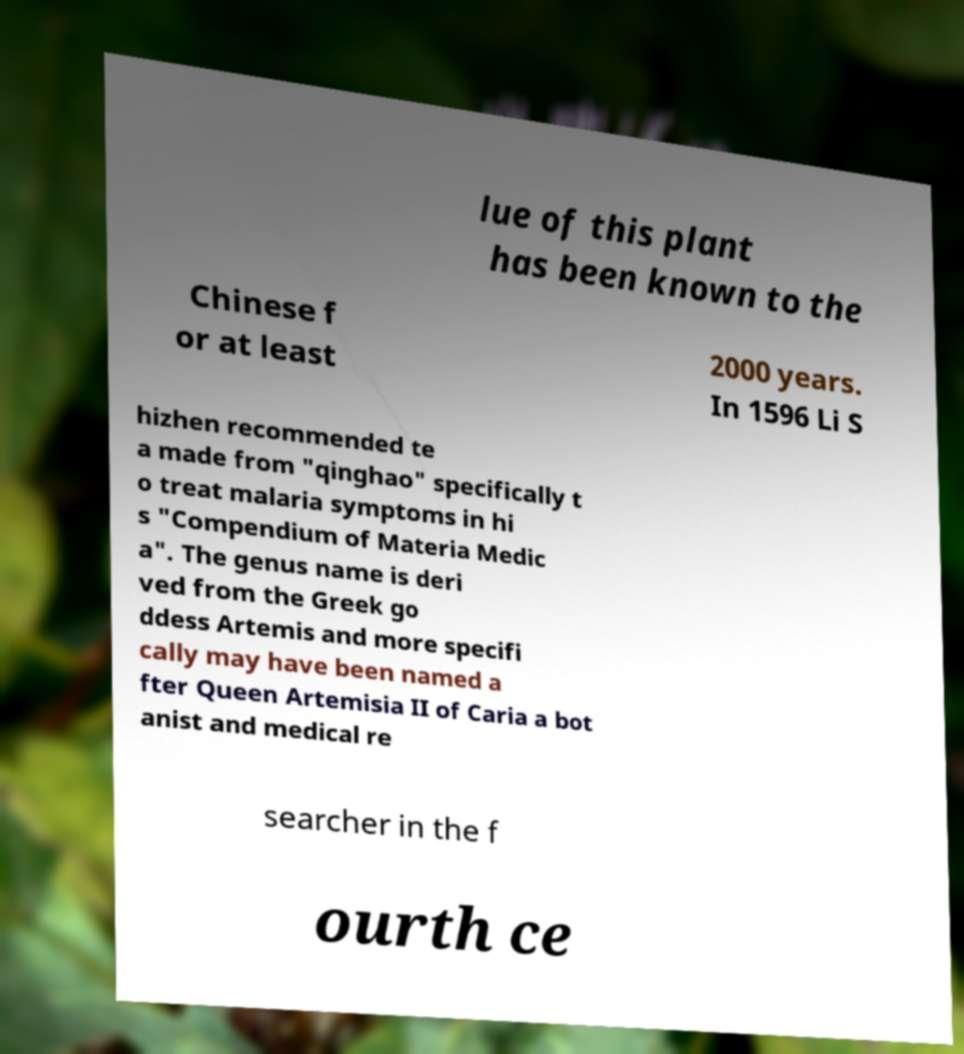I need the written content from this picture converted into text. Can you do that? lue of this plant has been known to the Chinese f or at least 2000 years. In 1596 Li S hizhen recommended te a made from "qinghao" specifically t o treat malaria symptoms in hi s "Compendium of Materia Medic a". The genus name is deri ved from the Greek go ddess Artemis and more specifi cally may have been named a fter Queen Artemisia II of Caria a bot anist and medical re searcher in the f ourth ce 